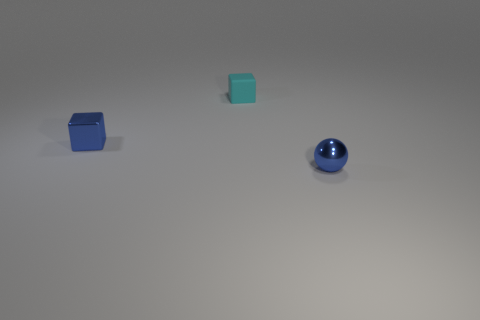There is a tiny blue metallic object on the right side of the small blue metallic object that is to the left of the tiny blue sphere in front of the tiny metal block; what shape is it?
Offer a very short reply. Sphere. There is a thing that is both in front of the tiny cyan matte object and on the right side of the metal block; what is its material?
Your answer should be compact. Metal. Do the metallic object behind the blue shiny ball and the tiny rubber cube have the same size?
Offer a terse response. Yes. Is there anything else that has the same size as the blue shiny ball?
Offer a terse response. Yes. Are there more tiny blue balls left of the cyan matte thing than small cubes to the right of the tiny blue metal ball?
Ensure brevity in your answer.  No. There is a small shiny object right of the metallic thing that is behind the tiny thing that is on the right side of the matte thing; what is its color?
Your answer should be very brief. Blue. Does the metal thing that is left of the tiny cyan matte cube have the same color as the small shiny sphere?
Keep it short and to the point. Yes. How many other objects are there of the same color as the metallic block?
Make the answer very short. 1. How many objects are tiny cubes or blue metal objects?
Give a very brief answer. 3. How many things are brown things or blue metal things in front of the tiny cyan rubber object?
Offer a terse response. 2. 